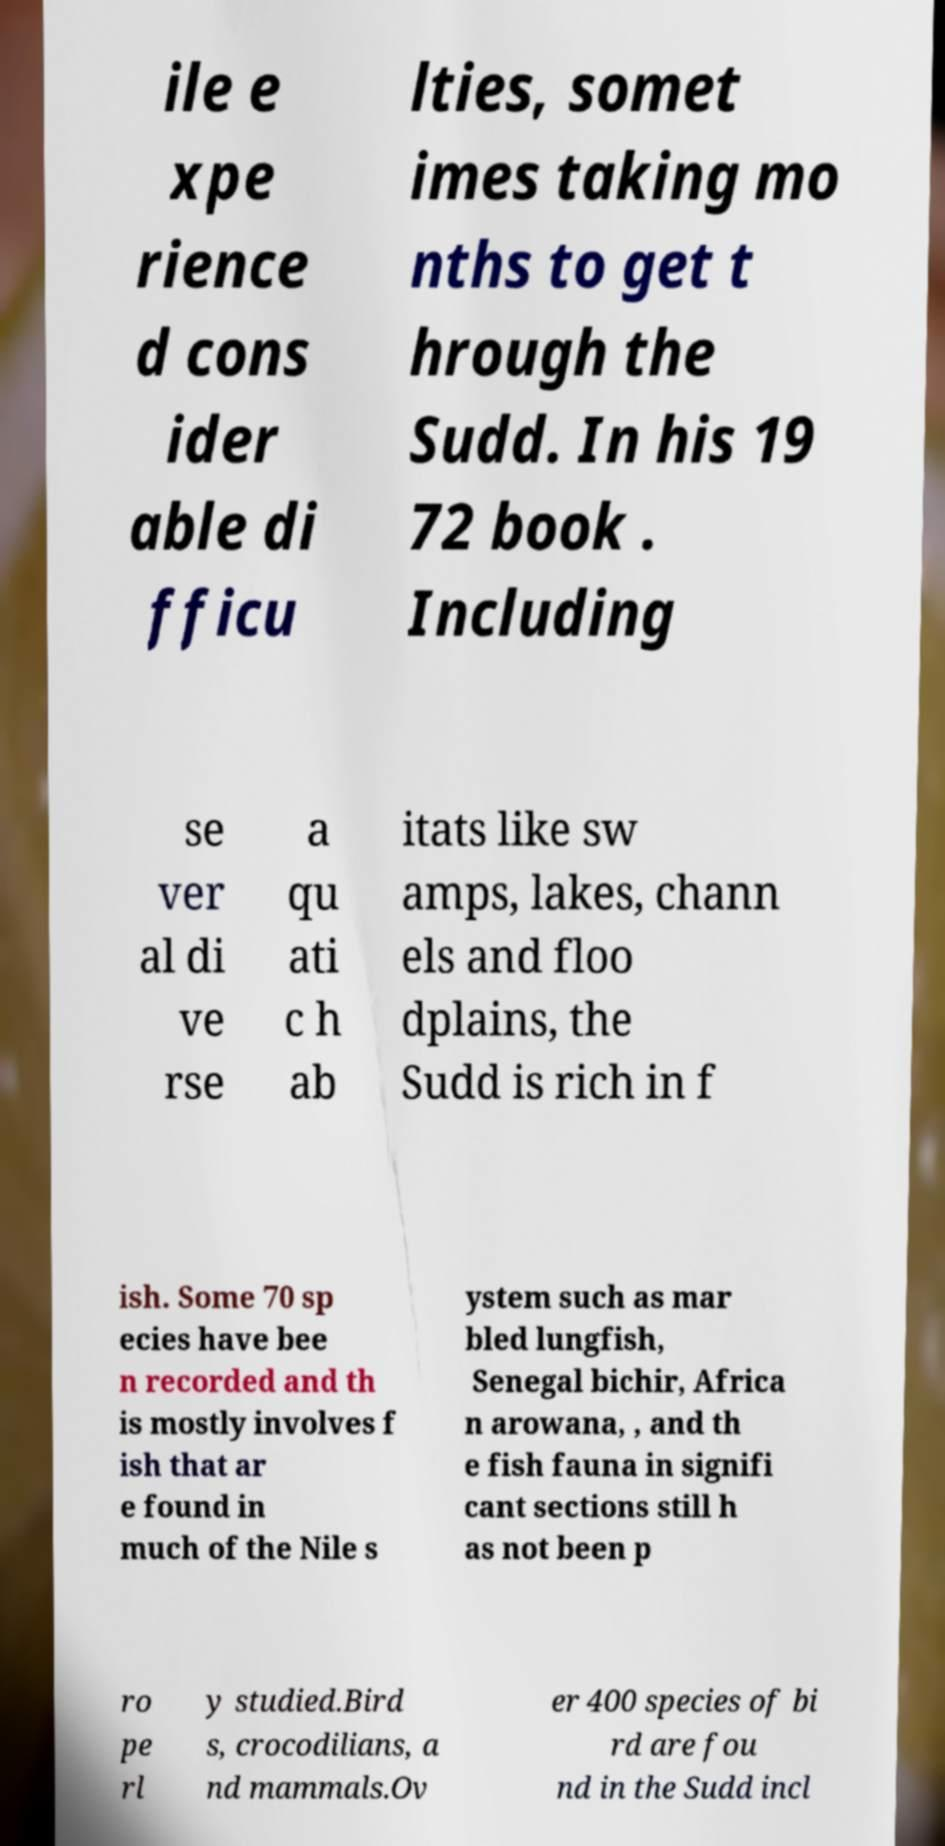Please identify and transcribe the text found in this image. ile e xpe rience d cons ider able di fficu lties, somet imes taking mo nths to get t hrough the Sudd. In his 19 72 book . Including se ver al di ve rse a qu ati c h ab itats like sw amps, lakes, chann els and floo dplains, the Sudd is rich in f ish. Some 70 sp ecies have bee n recorded and th is mostly involves f ish that ar e found in much of the Nile s ystem such as mar bled lungfish, Senegal bichir, Africa n arowana, , and th e fish fauna in signifi cant sections still h as not been p ro pe rl y studied.Bird s, crocodilians, a nd mammals.Ov er 400 species of bi rd are fou nd in the Sudd incl 